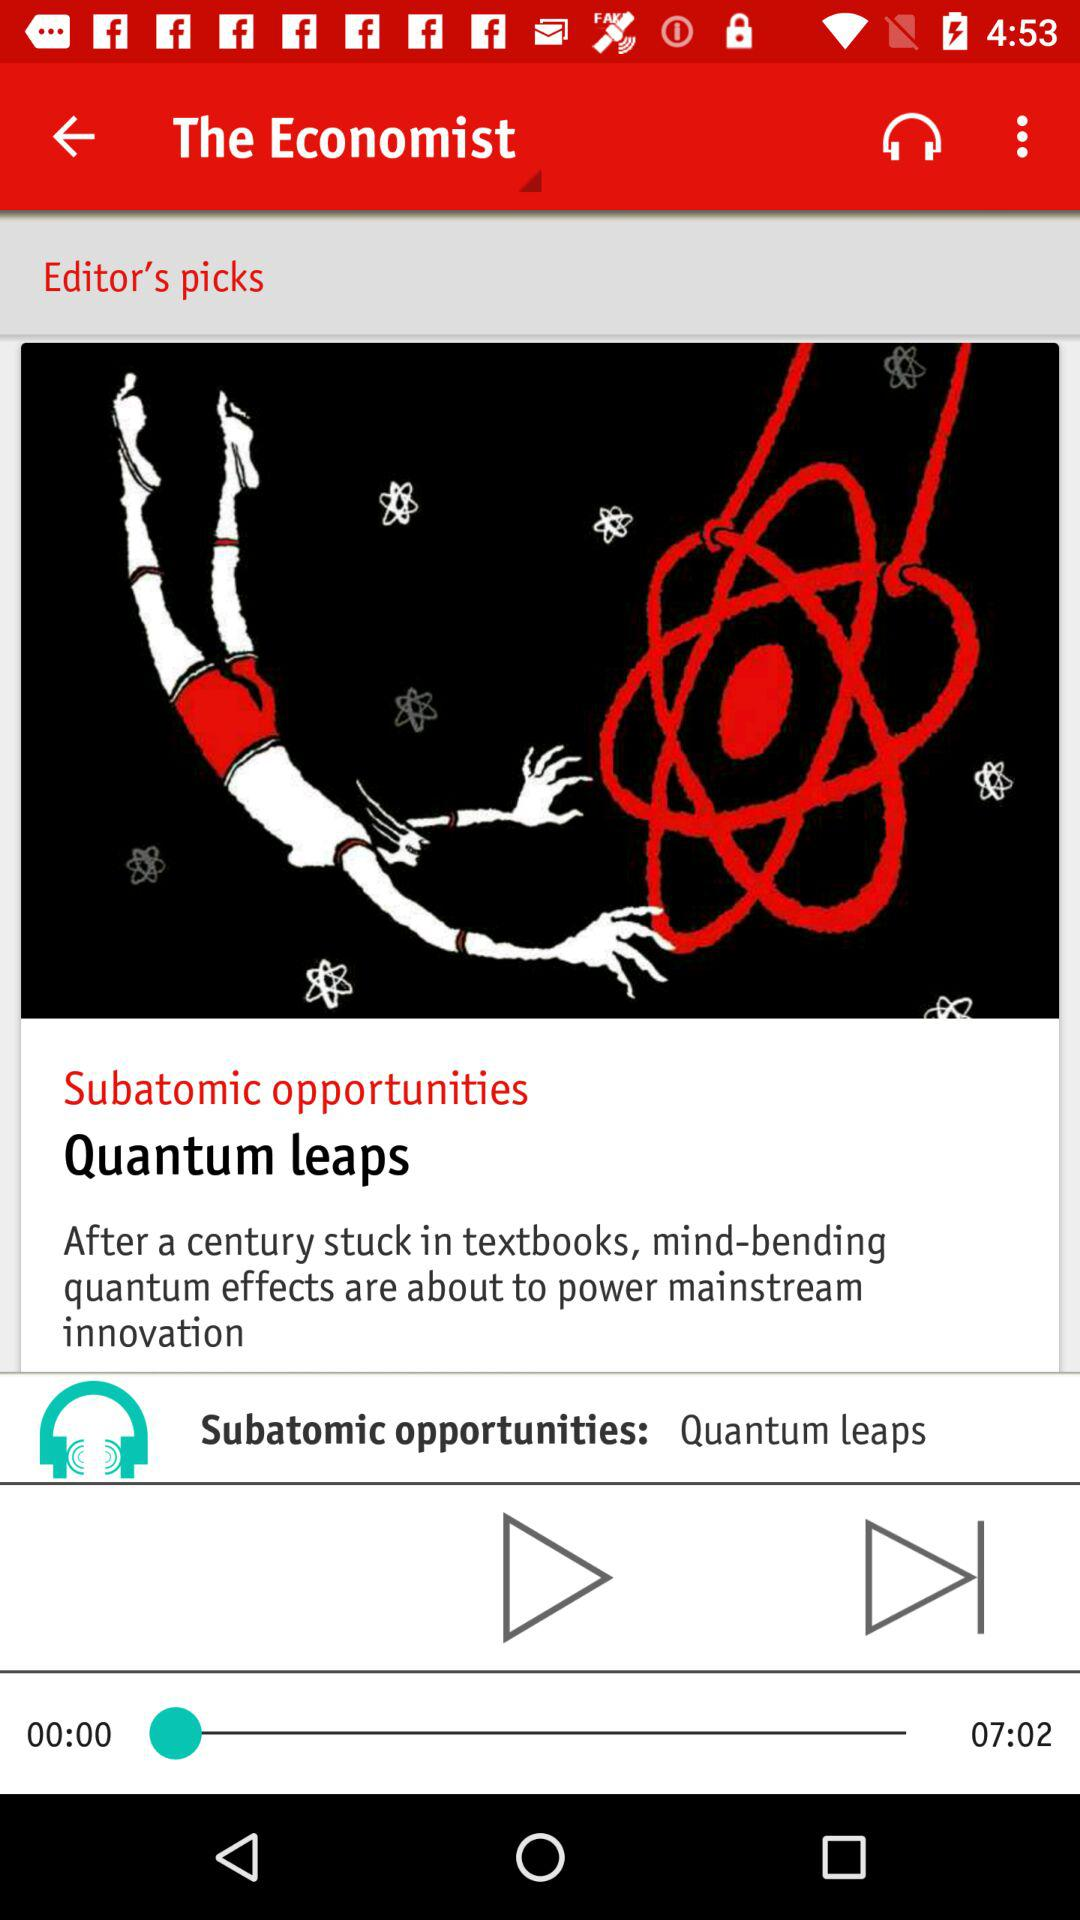What is the app name?
When the provided information is insufficient, respond with <no answer>. <no answer> 